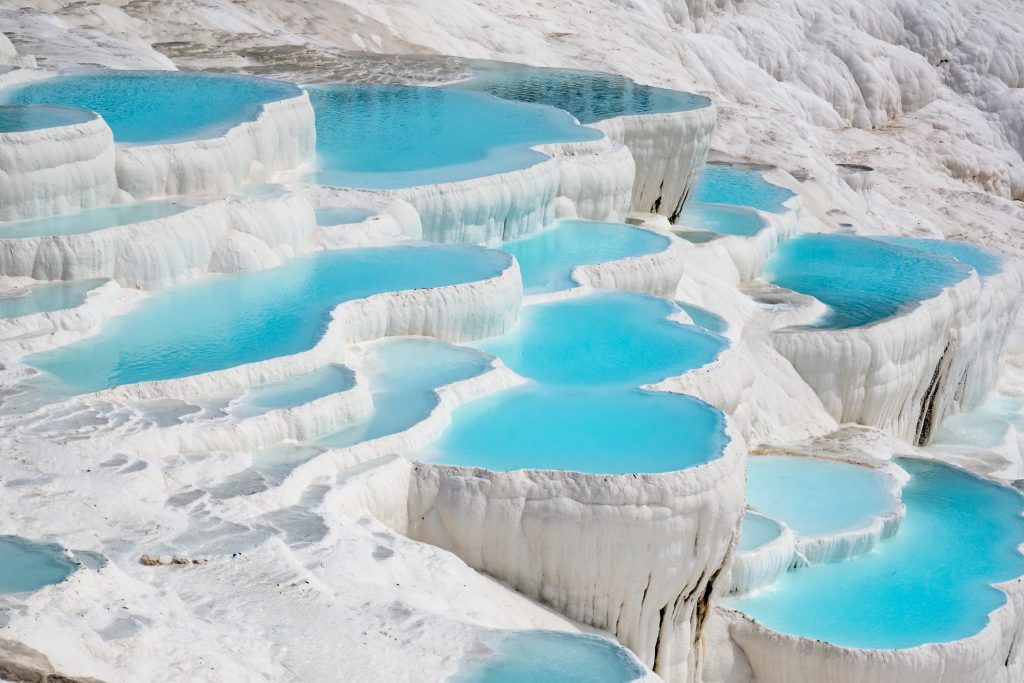If Pamukkale was a magical land, what kind of mythical creatures would inhabit its terraces? In a magical land like Pamukkale, the terraces might be home to mythical creatures such as Water Nymphs, who dwell in the sparkling azure pools and sing enchanting melodies that echo through the travertine cascades. Majestic Pegasus, the winged horses, might graze gracefully on the terrace ledges, their hooves barely touching the ground. Additionally, you might encounter Luminescent Fairies, whose iridescent wings illuminate the crystal-clear waters at night, creating a mesmerizing light show seen only by the lucky few. This enchanted backdrop, with its ethereal beauty and serene ambiance, is perfectly suited for such wondrous beings. 